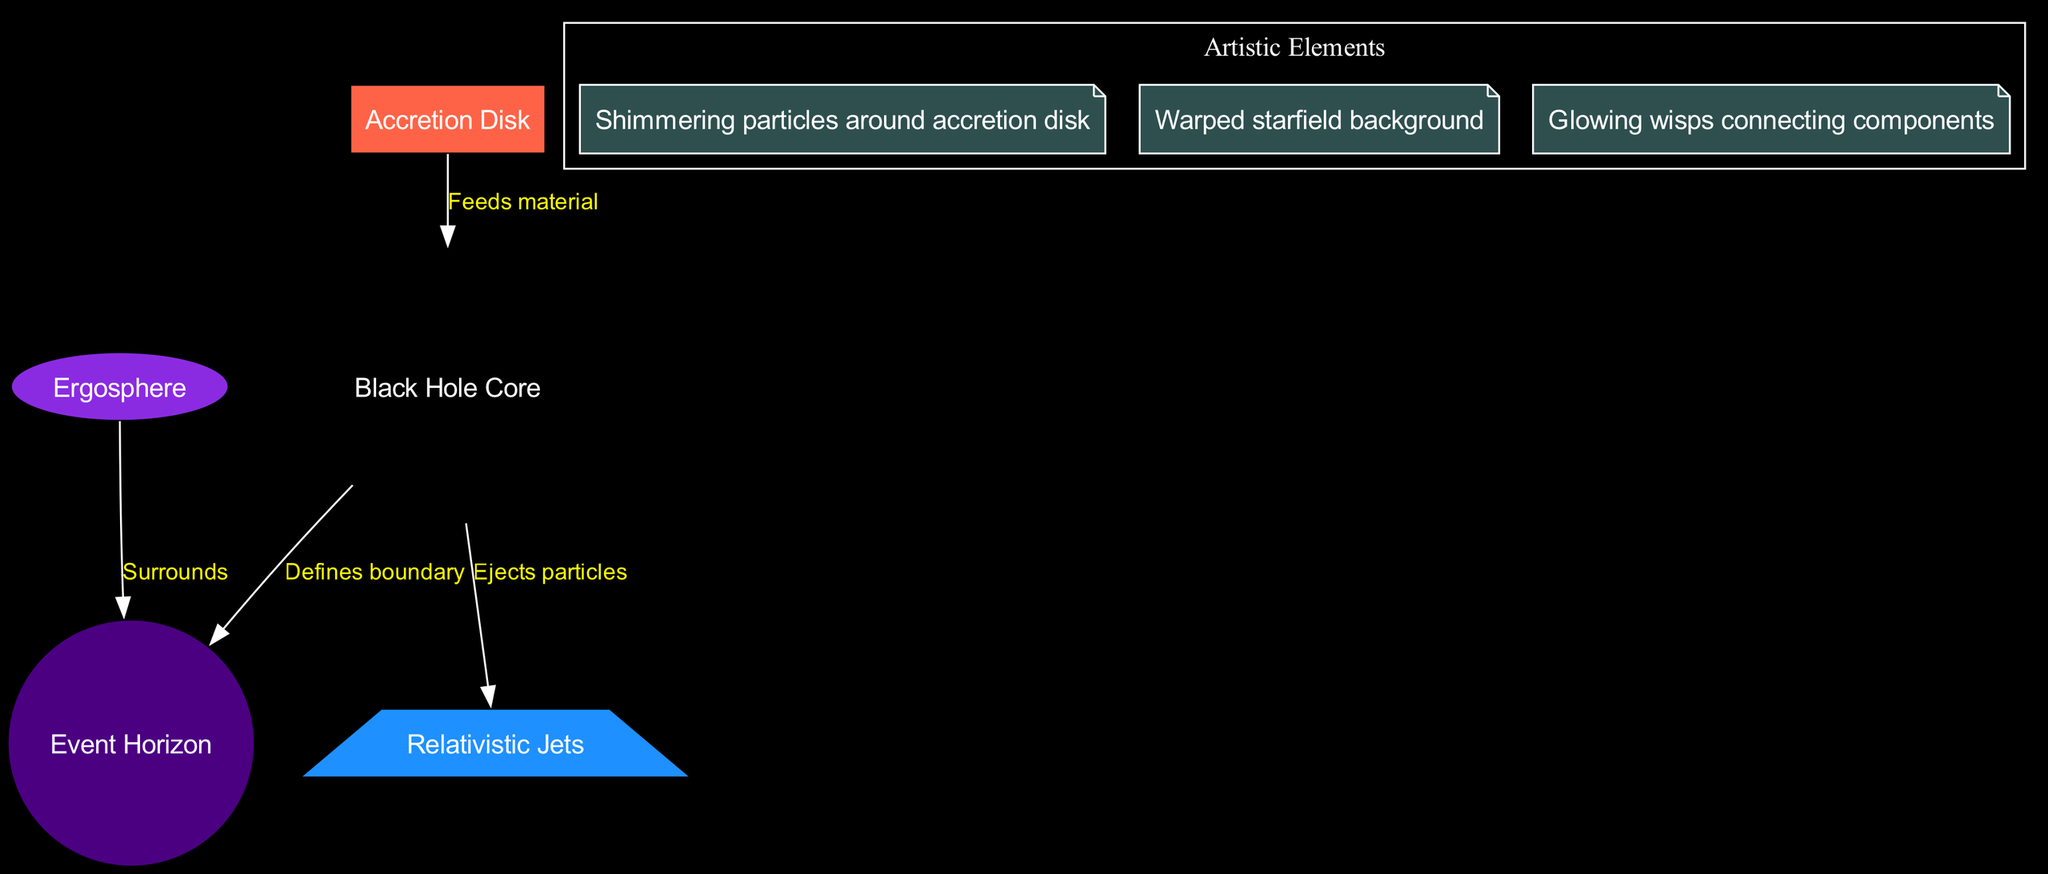What is the label of the node representing the point of no return? The node representing the point of no return is labeled "Event Horizon," which is defined as the location from which nothing can escape, including light.
Answer: Event Horizon How many nodes are in the diagram? The diagram contains five nodes that represent various components of a black hole: the Black Hole Core, Event Horizon, Accretion Disk, Relativistic Jets, and Ergosphere.
Answer: 5 What concept does the "Relativistic Jets" node represent? The "Relativistic Jets" node represents high-energy particle beams that are ejected from the poles of the black hole. This indicates the dynamic processes occurring at a black hole's extremes.
Answer: High-energy particle beams What is the relationship between the black hole and the accretion disk? The relationship is that the accretion disk feeds material into the black hole, meaning that the swirling matter in the disk contributes to the mass of the black hole.
Answer: Feeds material Which artistic element is described as "Shimmering particles around accretion disk"? The artistic element that represents shimmering particles around the accretion disk is labeled "Cosmic Dust." It adds an aesthetic layer to the diagram, highlighting the beauty of the black hole's environment.
Answer: Cosmic Dust What surrounds the event horizon in the structure? The "Ergosphere" surrounds the event horizon, indicating a region of space-time where the effects of the black hole's rotation are felt and can influence the movement of matter.
Answer: Ergosphere What type of structure does the "Black Hole Core" represent? The "Black Hole Core" is characterized as a singularity with infinite density, marking it as the core fundamental of a black hole where gravitational effects are maximized.
Answer: Singularity with infinite density How do relativistic jets connect to the black hole? Relativistic jets are ejected from the black hole, indicating that they are a direct result of the processes occurring in the vicinity of the black hole at its poles.
Answer: Ejects particles 